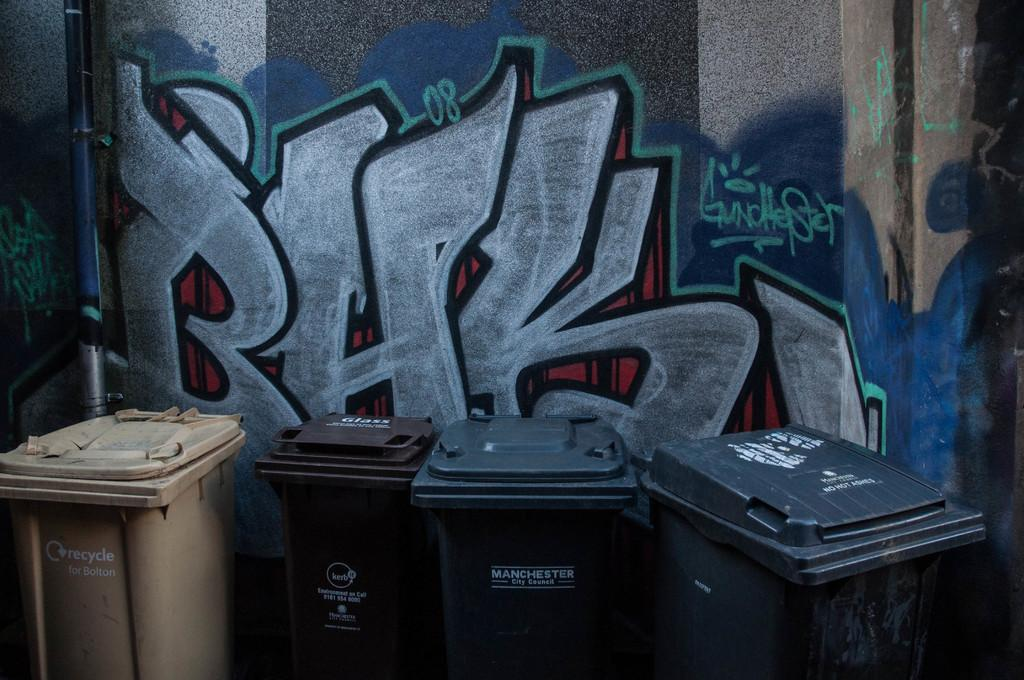How many garbage bins are visible in the image? There are four garbage bins in the image. What can be seen in the background of the image? There is a wall in the background of the image. What is featured on the wall? Graffiti art is present on the wall. Can you describe the face of the person who created the graffiti art in the image? There is no face visible in the image, as it only features the graffiti art on the wall and not the creator. 